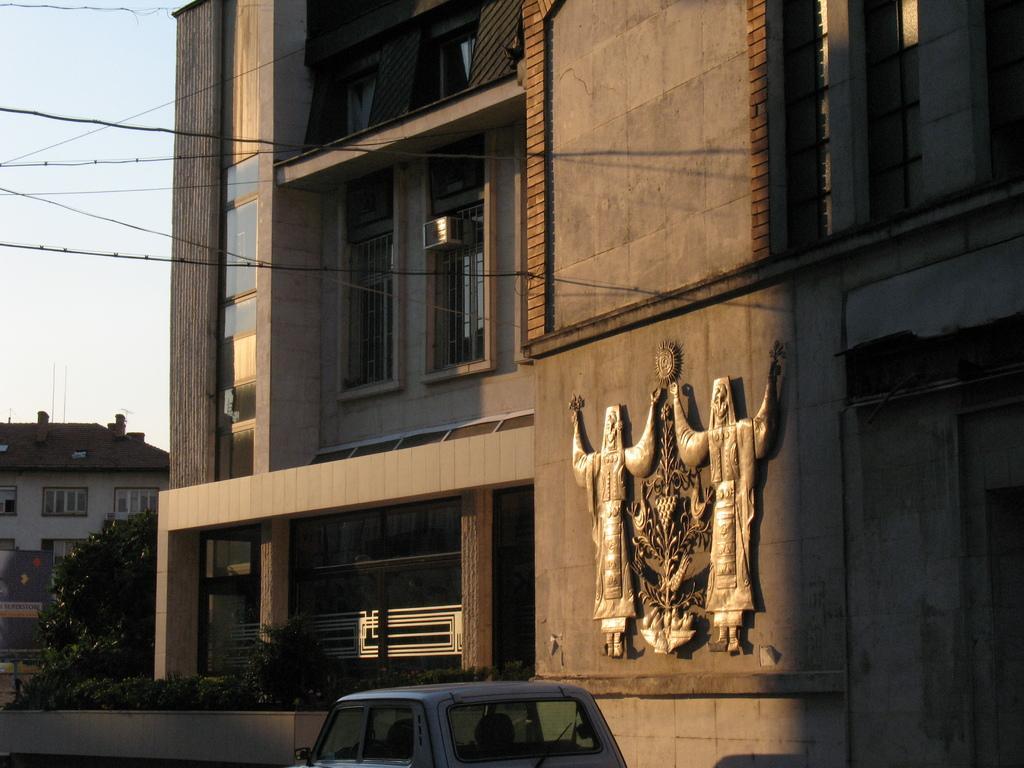What type of structures can be seen in the image? There are buildings in the image. What mode of transportation is visible on the road? There is a car on the road in the image. What type of vegetation is near the building? There are trees beside the building in the image. What type of infrastructure is present in the image? Cables are present in the image. Can you tell me how many servants are attending to the afterthought in the image? There is no afterthought or servant present in the image. What type of man can be seen walking beside the car in the image? There is no man present in the image; only a car on the road can be seen. 